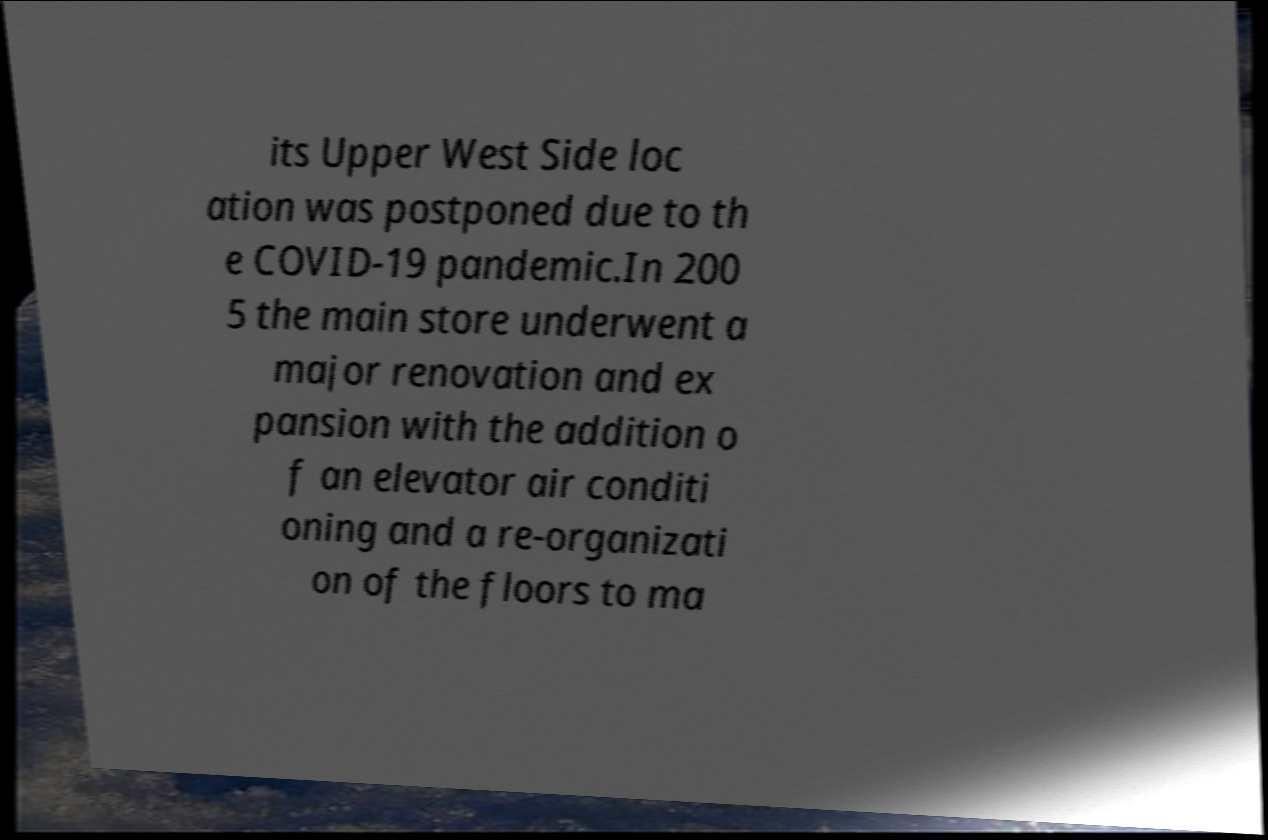Please identify and transcribe the text found in this image. its Upper West Side loc ation was postponed due to th e COVID-19 pandemic.In 200 5 the main store underwent a major renovation and ex pansion with the addition o f an elevator air conditi oning and a re-organizati on of the floors to ma 